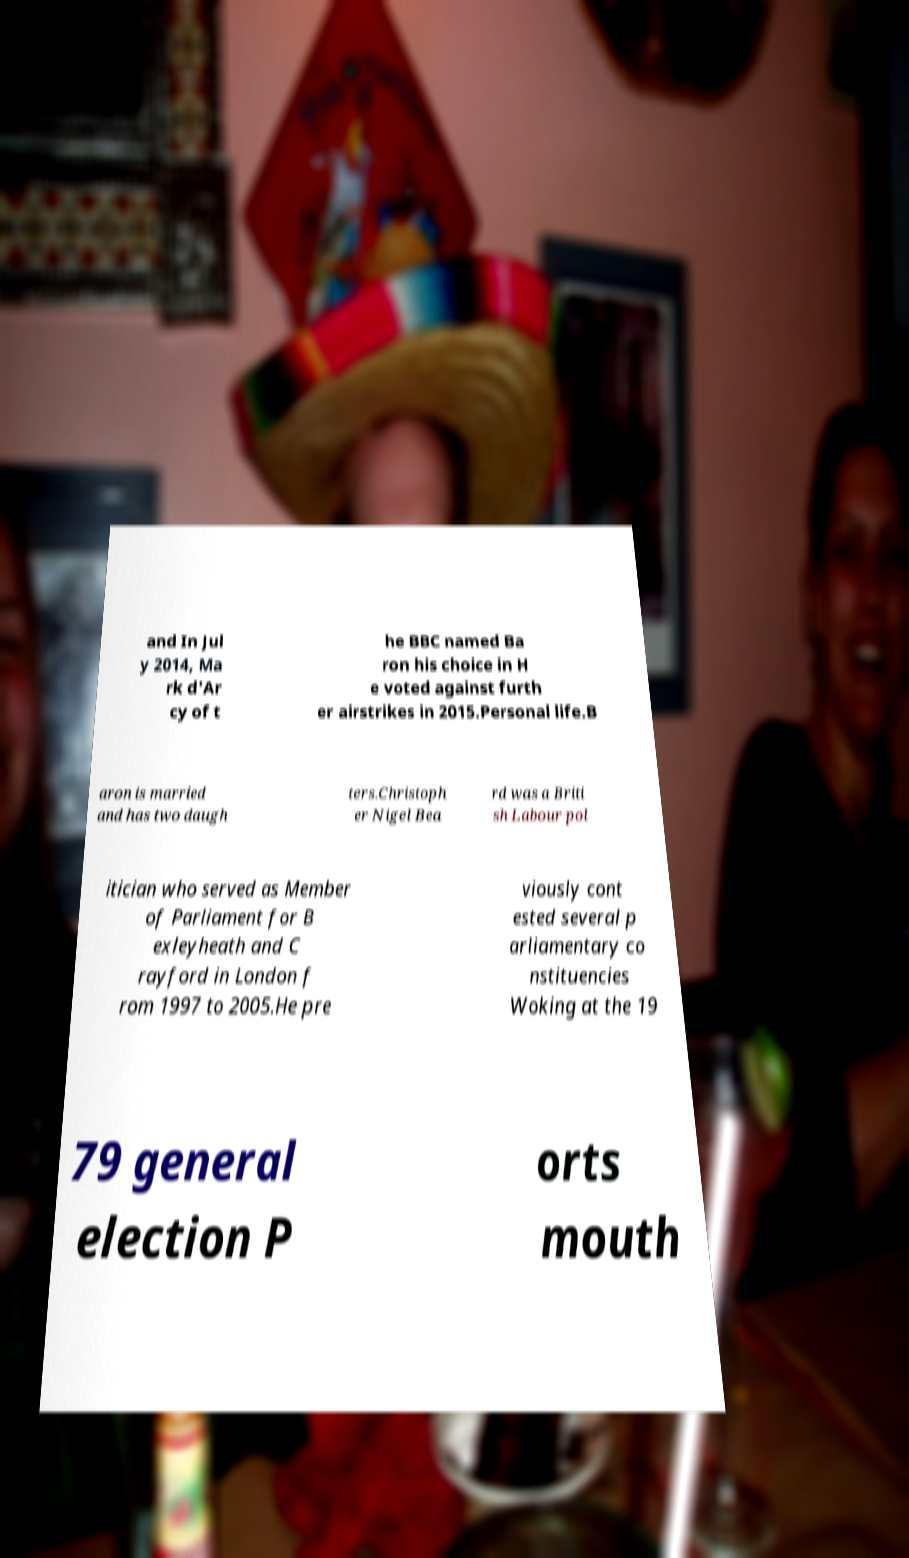Can you read and provide the text displayed in the image?This photo seems to have some interesting text. Can you extract and type it out for me? and In Jul y 2014, Ma rk d'Ar cy of t he BBC named Ba ron his choice in H e voted against furth er airstrikes in 2015.Personal life.B aron is married and has two daugh ters.Christoph er Nigel Bea rd was a Briti sh Labour pol itician who served as Member of Parliament for B exleyheath and C rayford in London f rom 1997 to 2005.He pre viously cont ested several p arliamentary co nstituencies Woking at the 19 79 general election P orts mouth 